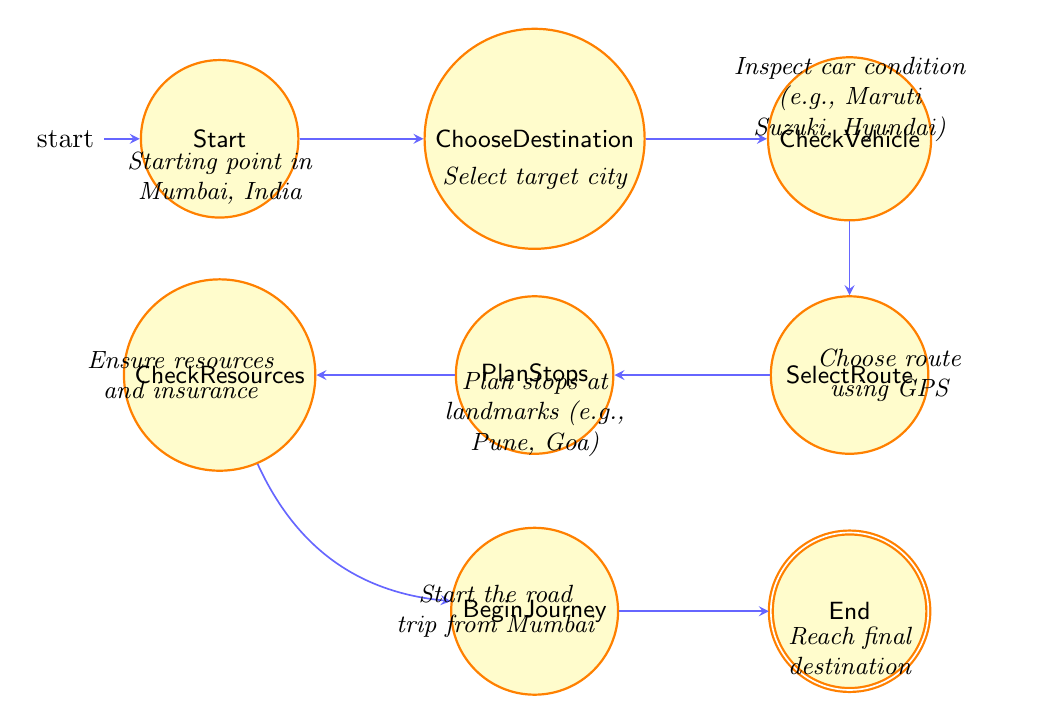What is the starting node of the diagram? The diagram begins with the 'Start' node, which represents the initial point of the road trip in Mumbai, India.
Answer: Start How many transitions are there from the 'PlanStops' node? From the 'PlanStops' node, there is one transition to the 'CheckResources' node, indicating the next step in the flow after planning stops.
Answer: 1 What is the final node in this finite state machine? The last node in the sequence, after 'BeginJourney', is 'End', marking the conclusion of the road trip when the destination is reached.
Answer: End What comes after the 'ChooseDestination' node? The next step following the 'ChooseDestination' node is 'CheckVehicle', where the vehicle's condition is inspected before proceeding.
Answer: CheckVehicle What type of resources need to be checked before starting the journey? Before commencing the journey, the resources that need to be checked include food, water, fuel, and insurance coverage, which are essential for a safe and prepared trip.
Answer: food, water, fuel, insurance Explain the relationship between 'CheckVehicle' and 'SelectRoute'. Upon completing the 'CheckVehicle' state, where the car's condition is verified, the process moves forward to the 'SelectRoute' state, where the route for the trip is chosen through a GPS navigation system.
Answer: Choose route using GPS If the trip starts, what is the next step after 'CheckResources'? After ensuring that all resources are prepared in the 'CheckResources' node, the next step is to 'BeginJourney', which indicates the actual start of the trip.
Answer: BeginJourney What major stops are planned before reaching the destination? The stops that are planned include major landmarks and rest points like Pune, Nashik, and Goa, which are popular along the road trip route from Mumbai.
Answer: Pune, Nashik, Goa How many nodes are there in total in this finite state machine? The finite state machine consists of a total of 7 distinct nodes that depict the various stages of planning and executing a road trip.
Answer: 7 